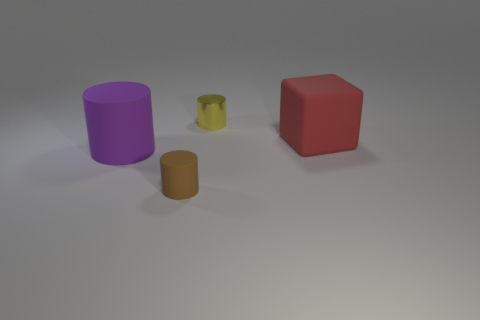There is a small yellow thing that is the same shape as the big purple matte object; what is its material?
Make the answer very short. Metal. There is a red thing that is the same material as the brown object; what shape is it?
Make the answer very short. Cube. How many other objects are there of the same color as the shiny object?
Provide a short and direct response. 0. What is the material of the purple cylinder?
Make the answer very short. Rubber. Are there any big red shiny objects?
Ensure brevity in your answer.  No. Is the number of yellow metal cylinders on the left side of the big purple thing the same as the number of red matte objects?
Provide a short and direct response. No. Is there anything else that has the same material as the tiny yellow cylinder?
Give a very brief answer. No. How many tiny things are either brown things or yellow objects?
Provide a short and direct response. 2. Do the small thing that is on the left side of the yellow shiny thing and the small yellow object have the same material?
Offer a very short reply. No. What is the material of the tiny cylinder in front of the large thing that is left of the big red rubber thing?
Give a very brief answer. Rubber. 